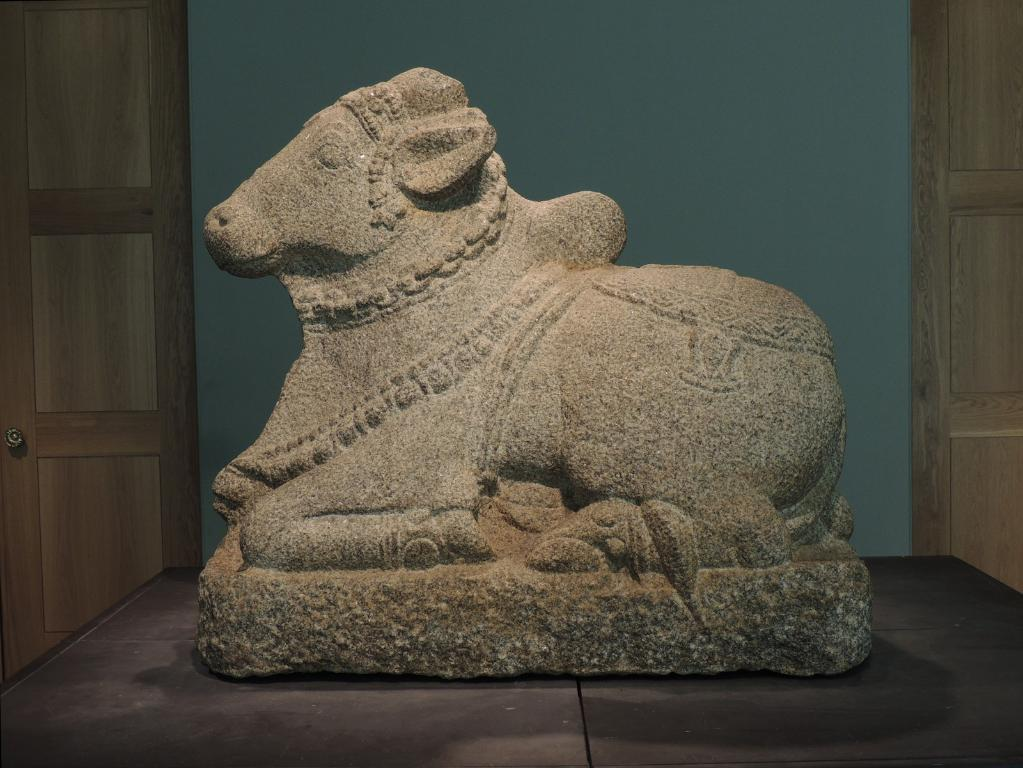What is the main subject in the center of the image? There is a sculpture in the center of the image. What can be seen in the background of the image? There is a wall and doors in the background of the image. What is located at the bottom of the image? There is a table at the bottom of the image. What type of lock is used on the doors in the image? There is no lock visible on the doors in the image. What color is the sweater worn by the sculpture in the image? The sculpture is not a person and does not wear a sweater; it is a non-living object and no clothing is present. 